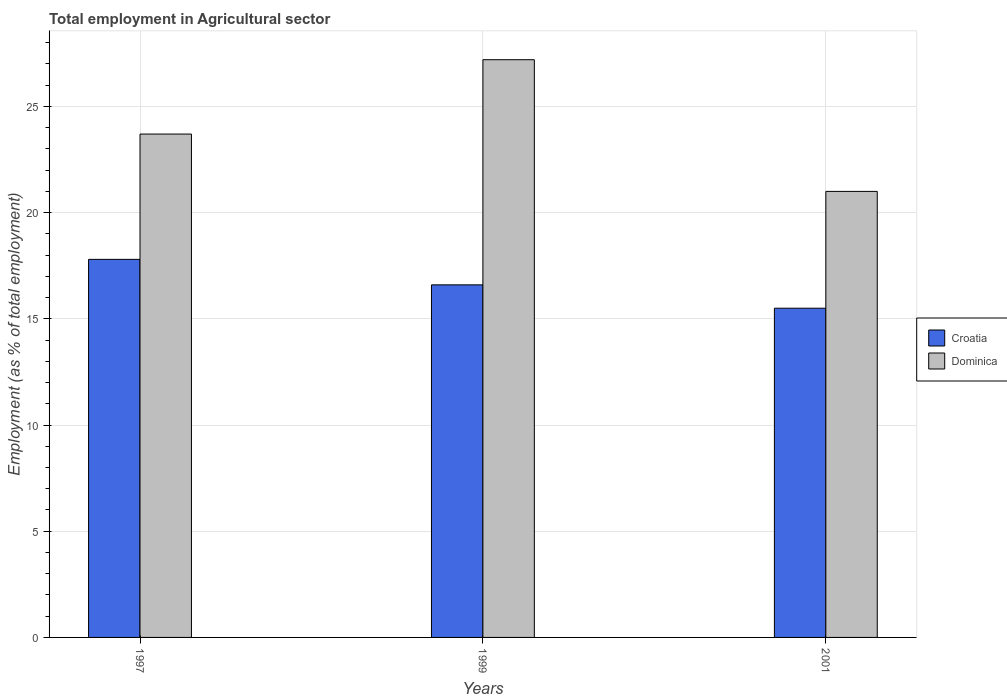How many groups of bars are there?
Provide a short and direct response. 3. Are the number of bars per tick equal to the number of legend labels?
Give a very brief answer. Yes. Are the number of bars on each tick of the X-axis equal?
Offer a very short reply. Yes. What is the label of the 2nd group of bars from the left?
Your response must be concise. 1999. What is the employment in agricultural sector in Croatia in 2001?
Keep it short and to the point. 15.5. Across all years, what is the maximum employment in agricultural sector in Dominica?
Your answer should be very brief. 27.2. Across all years, what is the minimum employment in agricultural sector in Croatia?
Ensure brevity in your answer.  15.5. What is the total employment in agricultural sector in Dominica in the graph?
Ensure brevity in your answer.  71.9. What is the difference between the employment in agricultural sector in Dominica in 1999 and that in 2001?
Give a very brief answer. 6.2. What is the difference between the employment in agricultural sector in Croatia in 1997 and the employment in agricultural sector in Dominica in 1999?
Offer a terse response. -9.4. What is the average employment in agricultural sector in Dominica per year?
Offer a very short reply. 23.97. In the year 1997, what is the difference between the employment in agricultural sector in Dominica and employment in agricultural sector in Croatia?
Offer a very short reply. 5.9. What is the ratio of the employment in agricultural sector in Croatia in 1999 to that in 2001?
Your answer should be very brief. 1.07. Is the employment in agricultural sector in Dominica in 1999 less than that in 2001?
Your response must be concise. No. Is the difference between the employment in agricultural sector in Dominica in 1997 and 1999 greater than the difference between the employment in agricultural sector in Croatia in 1997 and 1999?
Your response must be concise. No. What is the difference between the highest and the second highest employment in agricultural sector in Dominica?
Make the answer very short. 3.5. What is the difference between the highest and the lowest employment in agricultural sector in Croatia?
Provide a short and direct response. 2.3. Is the sum of the employment in agricultural sector in Croatia in 1997 and 1999 greater than the maximum employment in agricultural sector in Dominica across all years?
Keep it short and to the point. Yes. What does the 2nd bar from the left in 1999 represents?
Provide a succinct answer. Dominica. What does the 1st bar from the right in 1999 represents?
Your answer should be compact. Dominica. How many years are there in the graph?
Provide a short and direct response. 3. Are the values on the major ticks of Y-axis written in scientific E-notation?
Ensure brevity in your answer.  No. Does the graph contain any zero values?
Provide a short and direct response. No. Does the graph contain grids?
Offer a terse response. Yes. How many legend labels are there?
Make the answer very short. 2. How are the legend labels stacked?
Offer a terse response. Vertical. What is the title of the graph?
Your answer should be very brief. Total employment in Agricultural sector. Does "Lower middle income" appear as one of the legend labels in the graph?
Provide a short and direct response. No. What is the label or title of the Y-axis?
Provide a succinct answer. Employment (as % of total employment). What is the Employment (as % of total employment) of Croatia in 1997?
Offer a terse response. 17.8. What is the Employment (as % of total employment) of Dominica in 1997?
Your answer should be compact. 23.7. What is the Employment (as % of total employment) of Croatia in 1999?
Your answer should be compact. 16.6. What is the Employment (as % of total employment) of Dominica in 1999?
Your answer should be very brief. 27.2. What is the Employment (as % of total employment) in Croatia in 2001?
Offer a very short reply. 15.5. Across all years, what is the maximum Employment (as % of total employment) in Croatia?
Offer a very short reply. 17.8. Across all years, what is the maximum Employment (as % of total employment) in Dominica?
Ensure brevity in your answer.  27.2. Across all years, what is the minimum Employment (as % of total employment) of Dominica?
Provide a short and direct response. 21. What is the total Employment (as % of total employment) in Croatia in the graph?
Provide a short and direct response. 49.9. What is the total Employment (as % of total employment) of Dominica in the graph?
Give a very brief answer. 71.9. What is the difference between the Employment (as % of total employment) in Croatia in 1997 and that in 1999?
Your answer should be compact. 1.2. What is the difference between the Employment (as % of total employment) in Dominica in 1999 and that in 2001?
Offer a very short reply. 6.2. What is the difference between the Employment (as % of total employment) in Croatia in 1997 and the Employment (as % of total employment) in Dominica in 1999?
Give a very brief answer. -9.4. What is the difference between the Employment (as % of total employment) in Croatia in 1997 and the Employment (as % of total employment) in Dominica in 2001?
Offer a terse response. -3.2. What is the difference between the Employment (as % of total employment) of Croatia in 1999 and the Employment (as % of total employment) of Dominica in 2001?
Offer a terse response. -4.4. What is the average Employment (as % of total employment) of Croatia per year?
Keep it short and to the point. 16.63. What is the average Employment (as % of total employment) of Dominica per year?
Provide a short and direct response. 23.97. In the year 1999, what is the difference between the Employment (as % of total employment) in Croatia and Employment (as % of total employment) in Dominica?
Your answer should be compact. -10.6. What is the ratio of the Employment (as % of total employment) of Croatia in 1997 to that in 1999?
Make the answer very short. 1.07. What is the ratio of the Employment (as % of total employment) in Dominica in 1997 to that in 1999?
Offer a terse response. 0.87. What is the ratio of the Employment (as % of total employment) in Croatia in 1997 to that in 2001?
Your answer should be very brief. 1.15. What is the ratio of the Employment (as % of total employment) in Dominica in 1997 to that in 2001?
Your response must be concise. 1.13. What is the ratio of the Employment (as % of total employment) in Croatia in 1999 to that in 2001?
Provide a succinct answer. 1.07. What is the ratio of the Employment (as % of total employment) of Dominica in 1999 to that in 2001?
Offer a very short reply. 1.3. What is the difference between the highest and the second highest Employment (as % of total employment) of Croatia?
Make the answer very short. 1.2. What is the difference between the highest and the second highest Employment (as % of total employment) in Dominica?
Provide a short and direct response. 3.5. What is the difference between the highest and the lowest Employment (as % of total employment) of Croatia?
Give a very brief answer. 2.3. 